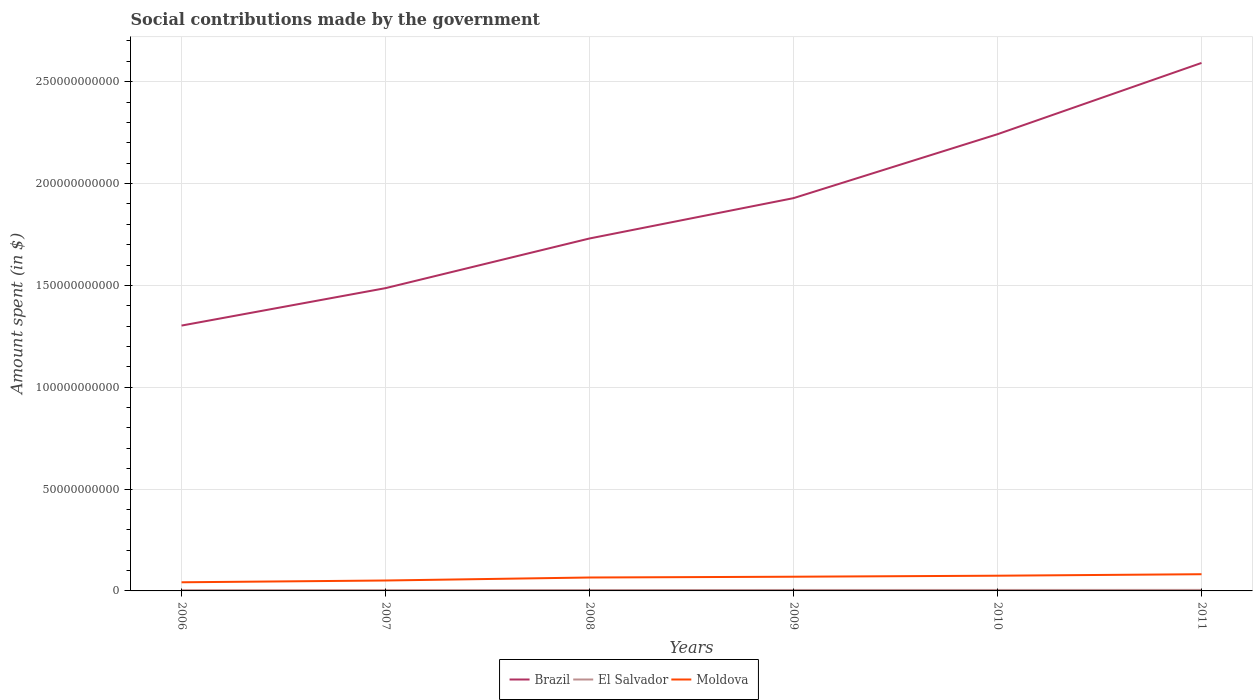Does the line corresponding to Moldova intersect with the line corresponding to Brazil?
Your response must be concise. No. Is the number of lines equal to the number of legend labels?
Your answer should be very brief. Yes. Across all years, what is the maximum amount spent on social contributions in Brazil?
Keep it short and to the point. 1.30e+11. What is the total amount spent on social contributions in Brazil in the graph?
Make the answer very short. -9.40e+1. What is the difference between the highest and the second highest amount spent on social contributions in El Salvador?
Ensure brevity in your answer.  1.34e+08. What is the difference between the highest and the lowest amount spent on social contributions in El Salvador?
Your answer should be compact. 3. How many years are there in the graph?
Provide a short and direct response. 6. What is the difference between two consecutive major ticks on the Y-axis?
Offer a very short reply. 5.00e+1. Does the graph contain any zero values?
Give a very brief answer. No. Does the graph contain grids?
Your answer should be very brief. Yes. Where does the legend appear in the graph?
Your response must be concise. Bottom center. How many legend labels are there?
Your response must be concise. 3. What is the title of the graph?
Your answer should be very brief. Social contributions made by the government. Does "Latvia" appear as one of the legend labels in the graph?
Give a very brief answer. No. What is the label or title of the Y-axis?
Provide a short and direct response. Amount spent (in $). What is the Amount spent (in $) of Brazil in 2006?
Offer a very short reply. 1.30e+11. What is the Amount spent (in $) of El Salvador in 2006?
Keep it short and to the point. 3.65e+08. What is the Amount spent (in $) of Moldova in 2006?
Provide a short and direct response. 4.24e+09. What is the Amount spent (in $) in Brazil in 2007?
Offer a very short reply. 1.49e+11. What is the Amount spent (in $) in El Salvador in 2007?
Offer a terse response. 3.91e+08. What is the Amount spent (in $) in Moldova in 2007?
Ensure brevity in your answer.  5.12e+09. What is the Amount spent (in $) in Brazil in 2008?
Provide a succinct answer. 1.73e+11. What is the Amount spent (in $) in El Salvador in 2008?
Give a very brief answer. 4.39e+08. What is the Amount spent (in $) of Moldova in 2008?
Give a very brief answer. 6.59e+09. What is the Amount spent (in $) of Brazil in 2009?
Provide a short and direct response. 1.93e+11. What is the Amount spent (in $) of El Salvador in 2009?
Make the answer very short. 4.65e+08. What is the Amount spent (in $) in Moldova in 2009?
Give a very brief answer. 6.97e+09. What is the Amount spent (in $) in Brazil in 2010?
Offer a terse response. 2.24e+11. What is the Amount spent (in $) of El Salvador in 2010?
Keep it short and to the point. 4.78e+08. What is the Amount spent (in $) of Moldova in 2010?
Your response must be concise. 7.47e+09. What is the Amount spent (in $) in Brazil in 2011?
Ensure brevity in your answer.  2.59e+11. What is the Amount spent (in $) of El Salvador in 2011?
Your answer should be compact. 4.99e+08. What is the Amount spent (in $) in Moldova in 2011?
Provide a succinct answer. 8.20e+09. Across all years, what is the maximum Amount spent (in $) in Brazil?
Your answer should be very brief. 2.59e+11. Across all years, what is the maximum Amount spent (in $) in El Salvador?
Your answer should be very brief. 4.99e+08. Across all years, what is the maximum Amount spent (in $) of Moldova?
Ensure brevity in your answer.  8.20e+09. Across all years, what is the minimum Amount spent (in $) in Brazil?
Offer a terse response. 1.30e+11. Across all years, what is the minimum Amount spent (in $) of El Salvador?
Provide a succinct answer. 3.65e+08. Across all years, what is the minimum Amount spent (in $) of Moldova?
Ensure brevity in your answer.  4.24e+09. What is the total Amount spent (in $) in Brazil in the graph?
Make the answer very short. 1.13e+12. What is the total Amount spent (in $) in El Salvador in the graph?
Ensure brevity in your answer.  2.64e+09. What is the total Amount spent (in $) in Moldova in the graph?
Provide a short and direct response. 3.86e+1. What is the difference between the Amount spent (in $) in Brazil in 2006 and that in 2007?
Give a very brief answer. -1.84e+1. What is the difference between the Amount spent (in $) in El Salvador in 2006 and that in 2007?
Provide a succinct answer. -2.59e+07. What is the difference between the Amount spent (in $) in Moldova in 2006 and that in 2007?
Your answer should be very brief. -8.72e+08. What is the difference between the Amount spent (in $) of Brazil in 2006 and that in 2008?
Keep it short and to the point. -4.28e+1. What is the difference between the Amount spent (in $) of El Salvador in 2006 and that in 2008?
Your answer should be compact. -7.40e+07. What is the difference between the Amount spent (in $) in Moldova in 2006 and that in 2008?
Your answer should be compact. -2.35e+09. What is the difference between the Amount spent (in $) in Brazil in 2006 and that in 2009?
Provide a succinct answer. -6.26e+1. What is the difference between the Amount spent (in $) of El Salvador in 2006 and that in 2009?
Offer a very short reply. -9.99e+07. What is the difference between the Amount spent (in $) in Moldova in 2006 and that in 2009?
Give a very brief answer. -2.73e+09. What is the difference between the Amount spent (in $) of Brazil in 2006 and that in 2010?
Offer a terse response. -9.40e+1. What is the difference between the Amount spent (in $) of El Salvador in 2006 and that in 2010?
Provide a succinct answer. -1.13e+08. What is the difference between the Amount spent (in $) in Moldova in 2006 and that in 2010?
Provide a succinct answer. -3.23e+09. What is the difference between the Amount spent (in $) of Brazil in 2006 and that in 2011?
Your answer should be very brief. -1.29e+11. What is the difference between the Amount spent (in $) of El Salvador in 2006 and that in 2011?
Make the answer very short. -1.34e+08. What is the difference between the Amount spent (in $) of Moldova in 2006 and that in 2011?
Your response must be concise. -3.95e+09. What is the difference between the Amount spent (in $) of Brazil in 2007 and that in 2008?
Keep it short and to the point. -2.44e+1. What is the difference between the Amount spent (in $) in El Salvador in 2007 and that in 2008?
Provide a short and direct response. -4.81e+07. What is the difference between the Amount spent (in $) of Moldova in 2007 and that in 2008?
Offer a very short reply. -1.47e+09. What is the difference between the Amount spent (in $) of Brazil in 2007 and that in 2009?
Your answer should be compact. -4.42e+1. What is the difference between the Amount spent (in $) of El Salvador in 2007 and that in 2009?
Provide a succinct answer. -7.40e+07. What is the difference between the Amount spent (in $) of Moldova in 2007 and that in 2009?
Provide a short and direct response. -1.86e+09. What is the difference between the Amount spent (in $) in Brazil in 2007 and that in 2010?
Give a very brief answer. -7.56e+1. What is the difference between the Amount spent (in $) in El Salvador in 2007 and that in 2010?
Provide a short and direct response. -8.69e+07. What is the difference between the Amount spent (in $) in Moldova in 2007 and that in 2010?
Your answer should be very brief. -2.36e+09. What is the difference between the Amount spent (in $) in Brazil in 2007 and that in 2011?
Your answer should be very brief. -1.11e+11. What is the difference between the Amount spent (in $) in El Salvador in 2007 and that in 2011?
Provide a short and direct response. -1.08e+08. What is the difference between the Amount spent (in $) in Moldova in 2007 and that in 2011?
Your response must be concise. -3.08e+09. What is the difference between the Amount spent (in $) in Brazil in 2008 and that in 2009?
Keep it short and to the point. -1.98e+1. What is the difference between the Amount spent (in $) of El Salvador in 2008 and that in 2009?
Ensure brevity in your answer.  -2.59e+07. What is the difference between the Amount spent (in $) of Moldova in 2008 and that in 2009?
Ensure brevity in your answer.  -3.82e+08. What is the difference between the Amount spent (in $) in Brazil in 2008 and that in 2010?
Provide a short and direct response. -5.12e+1. What is the difference between the Amount spent (in $) in El Salvador in 2008 and that in 2010?
Your answer should be very brief. -3.88e+07. What is the difference between the Amount spent (in $) of Moldova in 2008 and that in 2010?
Your response must be concise. -8.82e+08. What is the difference between the Amount spent (in $) of Brazil in 2008 and that in 2011?
Offer a terse response. -8.62e+1. What is the difference between the Amount spent (in $) in El Salvador in 2008 and that in 2011?
Offer a terse response. -6.02e+07. What is the difference between the Amount spent (in $) of Moldova in 2008 and that in 2011?
Your answer should be very brief. -1.61e+09. What is the difference between the Amount spent (in $) in Brazil in 2009 and that in 2010?
Give a very brief answer. -3.14e+1. What is the difference between the Amount spent (in $) in El Salvador in 2009 and that in 2010?
Give a very brief answer. -1.29e+07. What is the difference between the Amount spent (in $) of Moldova in 2009 and that in 2010?
Your answer should be compact. -5.00e+08. What is the difference between the Amount spent (in $) of Brazil in 2009 and that in 2011?
Offer a very short reply. -6.64e+1. What is the difference between the Amount spent (in $) in El Salvador in 2009 and that in 2011?
Offer a terse response. -3.43e+07. What is the difference between the Amount spent (in $) of Moldova in 2009 and that in 2011?
Your answer should be compact. -1.23e+09. What is the difference between the Amount spent (in $) in Brazil in 2010 and that in 2011?
Your response must be concise. -3.50e+1. What is the difference between the Amount spent (in $) in El Salvador in 2010 and that in 2011?
Your answer should be compact. -2.14e+07. What is the difference between the Amount spent (in $) in Moldova in 2010 and that in 2011?
Your answer should be very brief. -7.27e+08. What is the difference between the Amount spent (in $) in Brazil in 2006 and the Amount spent (in $) in El Salvador in 2007?
Provide a succinct answer. 1.30e+11. What is the difference between the Amount spent (in $) in Brazil in 2006 and the Amount spent (in $) in Moldova in 2007?
Offer a very short reply. 1.25e+11. What is the difference between the Amount spent (in $) of El Salvador in 2006 and the Amount spent (in $) of Moldova in 2007?
Your answer should be very brief. -4.75e+09. What is the difference between the Amount spent (in $) in Brazil in 2006 and the Amount spent (in $) in El Salvador in 2008?
Give a very brief answer. 1.30e+11. What is the difference between the Amount spent (in $) in Brazil in 2006 and the Amount spent (in $) in Moldova in 2008?
Provide a succinct answer. 1.24e+11. What is the difference between the Amount spent (in $) of El Salvador in 2006 and the Amount spent (in $) of Moldova in 2008?
Make the answer very short. -6.22e+09. What is the difference between the Amount spent (in $) of Brazil in 2006 and the Amount spent (in $) of El Salvador in 2009?
Your response must be concise. 1.30e+11. What is the difference between the Amount spent (in $) in Brazil in 2006 and the Amount spent (in $) in Moldova in 2009?
Your answer should be compact. 1.23e+11. What is the difference between the Amount spent (in $) of El Salvador in 2006 and the Amount spent (in $) of Moldova in 2009?
Provide a short and direct response. -6.61e+09. What is the difference between the Amount spent (in $) of Brazil in 2006 and the Amount spent (in $) of El Salvador in 2010?
Give a very brief answer. 1.30e+11. What is the difference between the Amount spent (in $) in Brazil in 2006 and the Amount spent (in $) in Moldova in 2010?
Give a very brief answer. 1.23e+11. What is the difference between the Amount spent (in $) of El Salvador in 2006 and the Amount spent (in $) of Moldova in 2010?
Provide a succinct answer. -7.11e+09. What is the difference between the Amount spent (in $) in Brazil in 2006 and the Amount spent (in $) in El Salvador in 2011?
Offer a terse response. 1.30e+11. What is the difference between the Amount spent (in $) in Brazil in 2006 and the Amount spent (in $) in Moldova in 2011?
Give a very brief answer. 1.22e+11. What is the difference between the Amount spent (in $) in El Salvador in 2006 and the Amount spent (in $) in Moldova in 2011?
Make the answer very short. -7.83e+09. What is the difference between the Amount spent (in $) of Brazil in 2007 and the Amount spent (in $) of El Salvador in 2008?
Your response must be concise. 1.48e+11. What is the difference between the Amount spent (in $) in Brazil in 2007 and the Amount spent (in $) in Moldova in 2008?
Offer a terse response. 1.42e+11. What is the difference between the Amount spent (in $) in El Salvador in 2007 and the Amount spent (in $) in Moldova in 2008?
Keep it short and to the point. -6.20e+09. What is the difference between the Amount spent (in $) of Brazil in 2007 and the Amount spent (in $) of El Salvador in 2009?
Offer a terse response. 1.48e+11. What is the difference between the Amount spent (in $) of Brazil in 2007 and the Amount spent (in $) of Moldova in 2009?
Keep it short and to the point. 1.42e+11. What is the difference between the Amount spent (in $) of El Salvador in 2007 and the Amount spent (in $) of Moldova in 2009?
Provide a succinct answer. -6.58e+09. What is the difference between the Amount spent (in $) of Brazil in 2007 and the Amount spent (in $) of El Salvador in 2010?
Your response must be concise. 1.48e+11. What is the difference between the Amount spent (in $) of Brazil in 2007 and the Amount spent (in $) of Moldova in 2010?
Give a very brief answer. 1.41e+11. What is the difference between the Amount spent (in $) of El Salvador in 2007 and the Amount spent (in $) of Moldova in 2010?
Offer a very short reply. -7.08e+09. What is the difference between the Amount spent (in $) in Brazil in 2007 and the Amount spent (in $) in El Salvador in 2011?
Ensure brevity in your answer.  1.48e+11. What is the difference between the Amount spent (in $) in Brazil in 2007 and the Amount spent (in $) in Moldova in 2011?
Your answer should be very brief. 1.40e+11. What is the difference between the Amount spent (in $) of El Salvador in 2007 and the Amount spent (in $) of Moldova in 2011?
Make the answer very short. -7.81e+09. What is the difference between the Amount spent (in $) of Brazil in 2008 and the Amount spent (in $) of El Salvador in 2009?
Provide a short and direct response. 1.73e+11. What is the difference between the Amount spent (in $) in Brazil in 2008 and the Amount spent (in $) in Moldova in 2009?
Give a very brief answer. 1.66e+11. What is the difference between the Amount spent (in $) of El Salvador in 2008 and the Amount spent (in $) of Moldova in 2009?
Provide a succinct answer. -6.53e+09. What is the difference between the Amount spent (in $) of Brazil in 2008 and the Amount spent (in $) of El Salvador in 2010?
Give a very brief answer. 1.73e+11. What is the difference between the Amount spent (in $) of Brazil in 2008 and the Amount spent (in $) of Moldova in 2010?
Keep it short and to the point. 1.66e+11. What is the difference between the Amount spent (in $) of El Salvador in 2008 and the Amount spent (in $) of Moldova in 2010?
Ensure brevity in your answer.  -7.03e+09. What is the difference between the Amount spent (in $) of Brazil in 2008 and the Amount spent (in $) of El Salvador in 2011?
Your answer should be compact. 1.73e+11. What is the difference between the Amount spent (in $) of Brazil in 2008 and the Amount spent (in $) of Moldova in 2011?
Offer a terse response. 1.65e+11. What is the difference between the Amount spent (in $) in El Salvador in 2008 and the Amount spent (in $) in Moldova in 2011?
Your answer should be compact. -7.76e+09. What is the difference between the Amount spent (in $) in Brazil in 2009 and the Amount spent (in $) in El Salvador in 2010?
Offer a terse response. 1.92e+11. What is the difference between the Amount spent (in $) of Brazil in 2009 and the Amount spent (in $) of Moldova in 2010?
Offer a terse response. 1.85e+11. What is the difference between the Amount spent (in $) of El Salvador in 2009 and the Amount spent (in $) of Moldova in 2010?
Your response must be concise. -7.01e+09. What is the difference between the Amount spent (in $) of Brazil in 2009 and the Amount spent (in $) of El Salvador in 2011?
Ensure brevity in your answer.  1.92e+11. What is the difference between the Amount spent (in $) of Brazil in 2009 and the Amount spent (in $) of Moldova in 2011?
Give a very brief answer. 1.85e+11. What is the difference between the Amount spent (in $) of El Salvador in 2009 and the Amount spent (in $) of Moldova in 2011?
Provide a short and direct response. -7.73e+09. What is the difference between the Amount spent (in $) of Brazil in 2010 and the Amount spent (in $) of El Salvador in 2011?
Make the answer very short. 2.24e+11. What is the difference between the Amount spent (in $) of Brazil in 2010 and the Amount spent (in $) of Moldova in 2011?
Offer a terse response. 2.16e+11. What is the difference between the Amount spent (in $) in El Salvador in 2010 and the Amount spent (in $) in Moldova in 2011?
Provide a short and direct response. -7.72e+09. What is the average Amount spent (in $) in Brazil per year?
Offer a very short reply. 1.88e+11. What is the average Amount spent (in $) of El Salvador per year?
Your response must be concise. 4.39e+08. What is the average Amount spent (in $) in Moldova per year?
Give a very brief answer. 6.43e+09. In the year 2006, what is the difference between the Amount spent (in $) in Brazil and Amount spent (in $) in El Salvador?
Offer a very short reply. 1.30e+11. In the year 2006, what is the difference between the Amount spent (in $) in Brazil and Amount spent (in $) in Moldova?
Offer a very short reply. 1.26e+11. In the year 2006, what is the difference between the Amount spent (in $) in El Salvador and Amount spent (in $) in Moldova?
Your response must be concise. -3.88e+09. In the year 2007, what is the difference between the Amount spent (in $) in Brazil and Amount spent (in $) in El Salvador?
Offer a very short reply. 1.48e+11. In the year 2007, what is the difference between the Amount spent (in $) in Brazil and Amount spent (in $) in Moldova?
Your response must be concise. 1.44e+11. In the year 2007, what is the difference between the Amount spent (in $) in El Salvador and Amount spent (in $) in Moldova?
Ensure brevity in your answer.  -4.73e+09. In the year 2008, what is the difference between the Amount spent (in $) of Brazil and Amount spent (in $) of El Salvador?
Your answer should be very brief. 1.73e+11. In the year 2008, what is the difference between the Amount spent (in $) in Brazil and Amount spent (in $) in Moldova?
Offer a very short reply. 1.66e+11. In the year 2008, what is the difference between the Amount spent (in $) in El Salvador and Amount spent (in $) in Moldova?
Offer a terse response. -6.15e+09. In the year 2009, what is the difference between the Amount spent (in $) in Brazil and Amount spent (in $) in El Salvador?
Ensure brevity in your answer.  1.92e+11. In the year 2009, what is the difference between the Amount spent (in $) of Brazil and Amount spent (in $) of Moldova?
Keep it short and to the point. 1.86e+11. In the year 2009, what is the difference between the Amount spent (in $) in El Salvador and Amount spent (in $) in Moldova?
Your response must be concise. -6.51e+09. In the year 2010, what is the difference between the Amount spent (in $) in Brazil and Amount spent (in $) in El Salvador?
Your response must be concise. 2.24e+11. In the year 2010, what is the difference between the Amount spent (in $) in Brazil and Amount spent (in $) in Moldova?
Make the answer very short. 2.17e+11. In the year 2010, what is the difference between the Amount spent (in $) of El Salvador and Amount spent (in $) of Moldova?
Your response must be concise. -6.99e+09. In the year 2011, what is the difference between the Amount spent (in $) in Brazil and Amount spent (in $) in El Salvador?
Keep it short and to the point. 2.59e+11. In the year 2011, what is the difference between the Amount spent (in $) of Brazil and Amount spent (in $) of Moldova?
Ensure brevity in your answer.  2.51e+11. In the year 2011, what is the difference between the Amount spent (in $) of El Salvador and Amount spent (in $) of Moldova?
Make the answer very short. -7.70e+09. What is the ratio of the Amount spent (in $) in Brazil in 2006 to that in 2007?
Provide a succinct answer. 0.88. What is the ratio of the Amount spent (in $) of El Salvador in 2006 to that in 2007?
Offer a very short reply. 0.93. What is the ratio of the Amount spent (in $) of Moldova in 2006 to that in 2007?
Ensure brevity in your answer.  0.83. What is the ratio of the Amount spent (in $) of Brazil in 2006 to that in 2008?
Ensure brevity in your answer.  0.75. What is the ratio of the Amount spent (in $) of El Salvador in 2006 to that in 2008?
Ensure brevity in your answer.  0.83. What is the ratio of the Amount spent (in $) of Moldova in 2006 to that in 2008?
Your answer should be compact. 0.64. What is the ratio of the Amount spent (in $) in Brazil in 2006 to that in 2009?
Provide a short and direct response. 0.68. What is the ratio of the Amount spent (in $) of El Salvador in 2006 to that in 2009?
Keep it short and to the point. 0.79. What is the ratio of the Amount spent (in $) in Moldova in 2006 to that in 2009?
Offer a terse response. 0.61. What is the ratio of the Amount spent (in $) in Brazil in 2006 to that in 2010?
Provide a short and direct response. 0.58. What is the ratio of the Amount spent (in $) of El Salvador in 2006 to that in 2010?
Provide a short and direct response. 0.76. What is the ratio of the Amount spent (in $) in Moldova in 2006 to that in 2010?
Make the answer very short. 0.57. What is the ratio of the Amount spent (in $) in Brazil in 2006 to that in 2011?
Your answer should be compact. 0.5. What is the ratio of the Amount spent (in $) of El Salvador in 2006 to that in 2011?
Your answer should be compact. 0.73. What is the ratio of the Amount spent (in $) of Moldova in 2006 to that in 2011?
Give a very brief answer. 0.52. What is the ratio of the Amount spent (in $) of Brazil in 2007 to that in 2008?
Ensure brevity in your answer.  0.86. What is the ratio of the Amount spent (in $) in El Salvador in 2007 to that in 2008?
Your answer should be very brief. 0.89. What is the ratio of the Amount spent (in $) of Moldova in 2007 to that in 2008?
Your answer should be very brief. 0.78. What is the ratio of the Amount spent (in $) of Brazil in 2007 to that in 2009?
Offer a terse response. 0.77. What is the ratio of the Amount spent (in $) in El Salvador in 2007 to that in 2009?
Keep it short and to the point. 0.84. What is the ratio of the Amount spent (in $) in Moldova in 2007 to that in 2009?
Offer a terse response. 0.73. What is the ratio of the Amount spent (in $) of Brazil in 2007 to that in 2010?
Keep it short and to the point. 0.66. What is the ratio of the Amount spent (in $) of El Salvador in 2007 to that in 2010?
Your answer should be compact. 0.82. What is the ratio of the Amount spent (in $) in Moldova in 2007 to that in 2010?
Provide a succinct answer. 0.68. What is the ratio of the Amount spent (in $) of Brazil in 2007 to that in 2011?
Your answer should be very brief. 0.57. What is the ratio of the Amount spent (in $) of El Salvador in 2007 to that in 2011?
Give a very brief answer. 0.78. What is the ratio of the Amount spent (in $) of Moldova in 2007 to that in 2011?
Your response must be concise. 0.62. What is the ratio of the Amount spent (in $) of Brazil in 2008 to that in 2009?
Keep it short and to the point. 0.9. What is the ratio of the Amount spent (in $) in El Salvador in 2008 to that in 2009?
Your response must be concise. 0.94. What is the ratio of the Amount spent (in $) of Moldova in 2008 to that in 2009?
Make the answer very short. 0.95. What is the ratio of the Amount spent (in $) in Brazil in 2008 to that in 2010?
Your answer should be very brief. 0.77. What is the ratio of the Amount spent (in $) of El Salvador in 2008 to that in 2010?
Offer a very short reply. 0.92. What is the ratio of the Amount spent (in $) of Moldova in 2008 to that in 2010?
Offer a very short reply. 0.88. What is the ratio of the Amount spent (in $) of Brazil in 2008 to that in 2011?
Offer a very short reply. 0.67. What is the ratio of the Amount spent (in $) of El Salvador in 2008 to that in 2011?
Keep it short and to the point. 0.88. What is the ratio of the Amount spent (in $) in Moldova in 2008 to that in 2011?
Provide a short and direct response. 0.8. What is the ratio of the Amount spent (in $) in Brazil in 2009 to that in 2010?
Make the answer very short. 0.86. What is the ratio of the Amount spent (in $) in El Salvador in 2009 to that in 2010?
Provide a short and direct response. 0.97. What is the ratio of the Amount spent (in $) of Moldova in 2009 to that in 2010?
Your answer should be compact. 0.93. What is the ratio of the Amount spent (in $) in Brazil in 2009 to that in 2011?
Provide a short and direct response. 0.74. What is the ratio of the Amount spent (in $) of El Salvador in 2009 to that in 2011?
Offer a very short reply. 0.93. What is the ratio of the Amount spent (in $) in Moldova in 2009 to that in 2011?
Offer a terse response. 0.85. What is the ratio of the Amount spent (in $) in Brazil in 2010 to that in 2011?
Give a very brief answer. 0.86. What is the ratio of the Amount spent (in $) in El Salvador in 2010 to that in 2011?
Your answer should be very brief. 0.96. What is the ratio of the Amount spent (in $) in Moldova in 2010 to that in 2011?
Offer a terse response. 0.91. What is the difference between the highest and the second highest Amount spent (in $) of Brazil?
Provide a short and direct response. 3.50e+1. What is the difference between the highest and the second highest Amount spent (in $) in El Salvador?
Keep it short and to the point. 2.14e+07. What is the difference between the highest and the second highest Amount spent (in $) in Moldova?
Offer a terse response. 7.27e+08. What is the difference between the highest and the lowest Amount spent (in $) of Brazil?
Give a very brief answer. 1.29e+11. What is the difference between the highest and the lowest Amount spent (in $) of El Salvador?
Ensure brevity in your answer.  1.34e+08. What is the difference between the highest and the lowest Amount spent (in $) of Moldova?
Ensure brevity in your answer.  3.95e+09. 